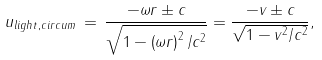Convert formula to latex. <formula><loc_0><loc_0><loc_500><loc_500>u _ { l i g h t , c i r c u m } \, = \, \frac { - \omega r \pm c } { { \sqrt { 1 - \left ( { \omega r } \right ) ^ { 2 } / c ^ { 2 } } } } = \frac { - v \pm c } { { \sqrt { 1 - v ^ { 2 } / c ^ { 2 } } } } ,</formula> 